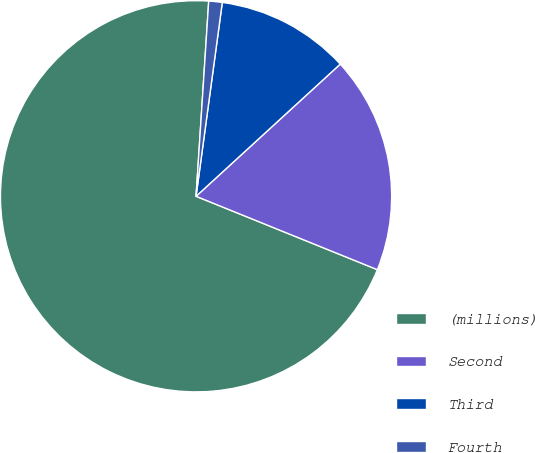<chart> <loc_0><loc_0><loc_500><loc_500><pie_chart><fcel>(millions)<fcel>Second<fcel>Third<fcel>Fourth<nl><fcel>69.91%<fcel>17.93%<fcel>11.05%<fcel>1.11%<nl></chart> 